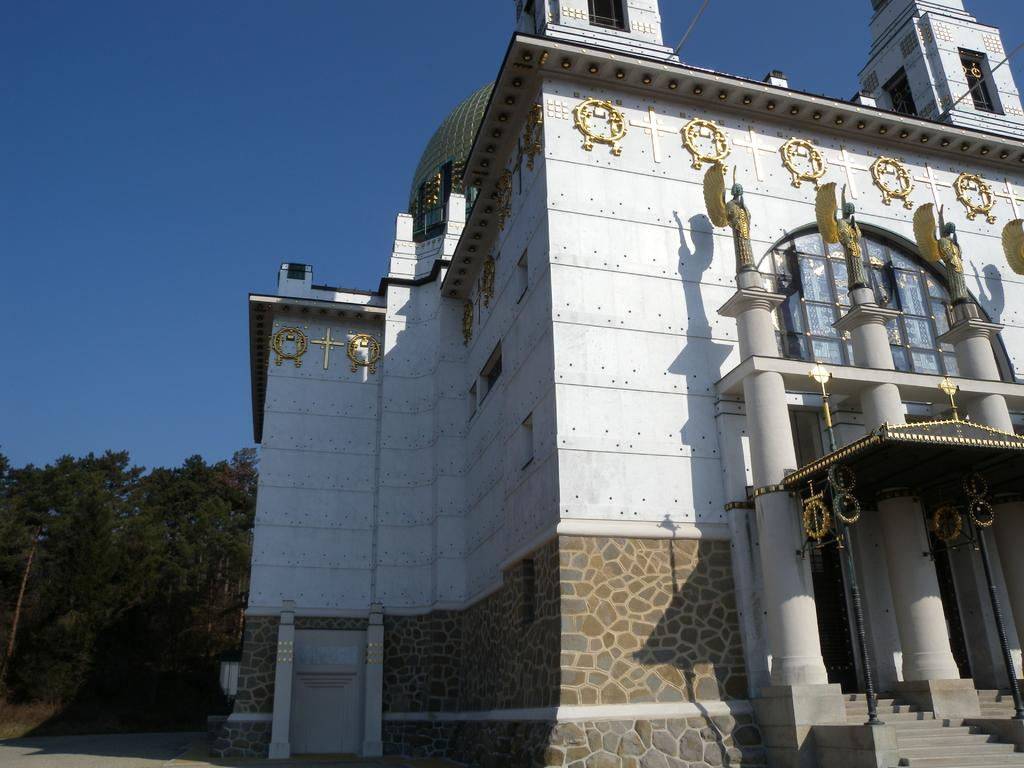What type of structure is visible in the image? There is a building in the image. What can be seen on top of the pillars in the image? There are statues on pillars in the image. What architectural feature is present in the image? There are steps in the image. What can be seen in the background of the image? Trees and the sky are visible in the background of the image. In which direction is the building facing in the image? The provided facts do not indicate the direction the building is facing. What type of tool is being used by the statue in the image? There is no tool visible in the image; the statues are not holding or using any objects. 